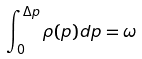<formula> <loc_0><loc_0><loc_500><loc_500>\int _ { 0 } ^ { \Delta p } \rho ( p ) d p = \omega</formula> 